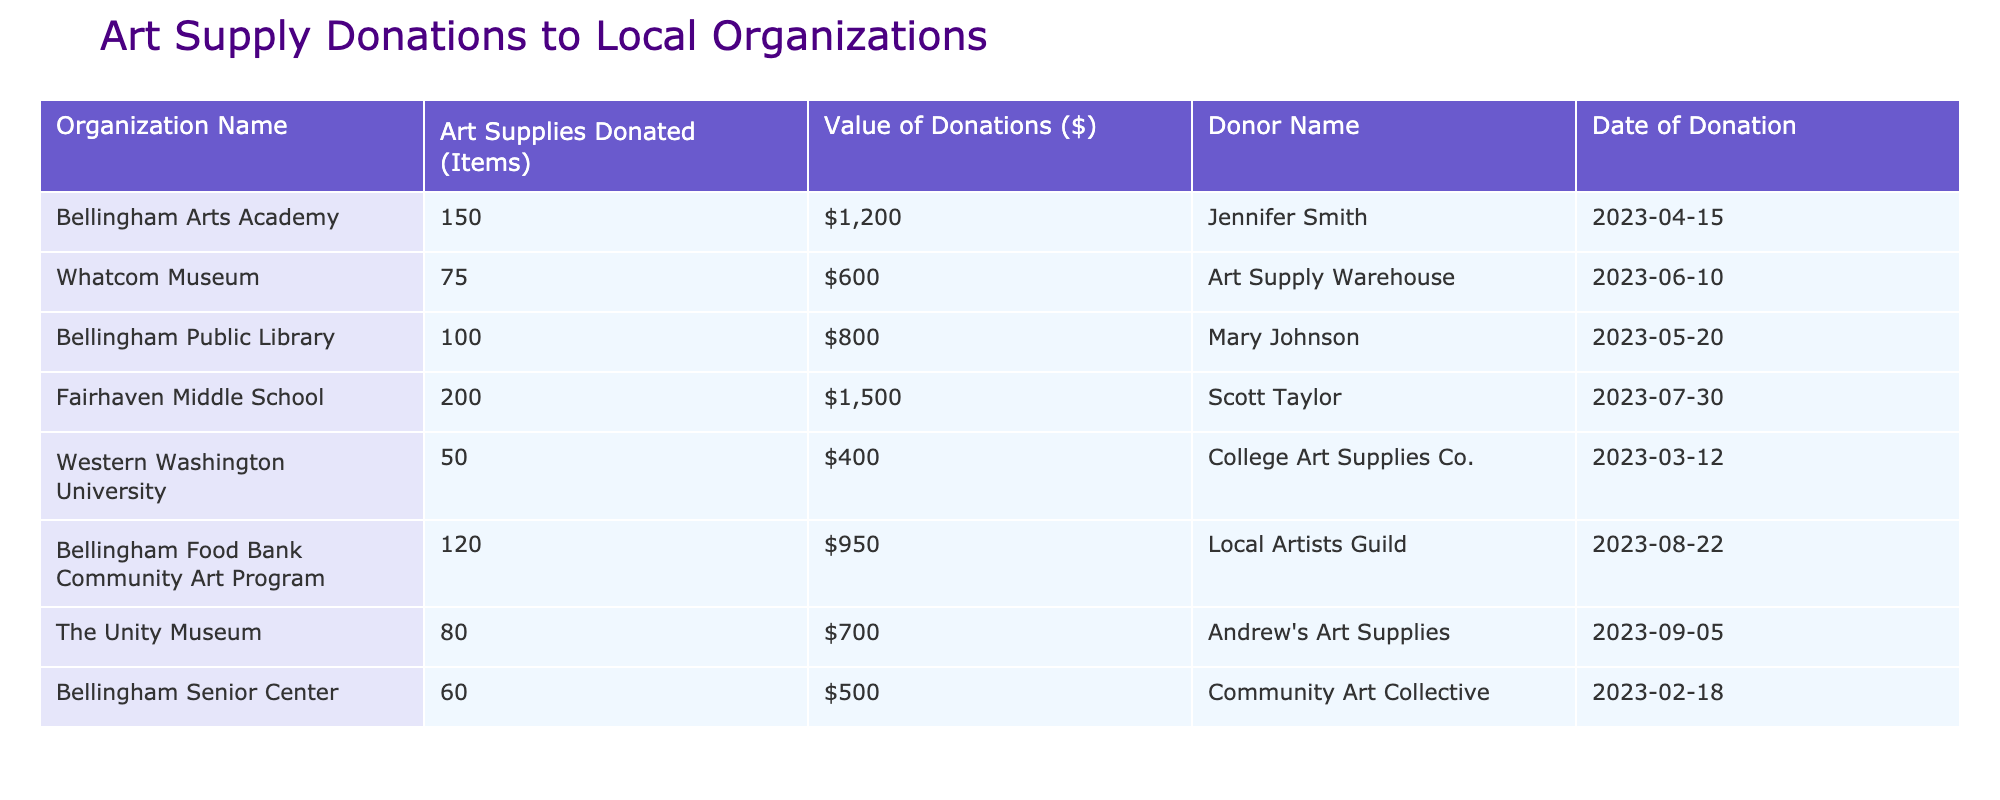What organization received the most art supplies? By examining the "Art Supplies Donated (Items)" column, Fairhaven Middle School has the highest number of items donated, with a total of 200.
Answer: Fairhaven Middle School What is the value of donations received by the Bellingham Public Library? Looking at the "Value of Donations ($)" column for the Bellingham Public Library, the value of donations is listed as $800.
Answer: $800 True or false: The Whatcom Museum received more than 500 dollars in art supply donations. The value of donations for the Whatcom Museum is $600, which is indeed greater than $500, making this statement true.
Answer: True What is the total number of items donated across all organizations? By summing the "Art Supplies Donated (Items)" column: 150 + 75 + 100 + 200 + 50 + 120 + 80 + 60 = 835. Therefore, the total number of items donated is 835.
Answer: 835 Which donor contributed to the highest value of donations and how much was donated? Analyzing the donor contributions, Scott Taylor donated to Fairhaven Middle School with a total value of $1,500, which is the highest among all donations.
Answer: $1,500 by Scott Taylor How many organizations received donations of more than 700 dollars? Looking at the "Value of Donations ($)" column, the organizations with donations exceeding $700 are Fairhaven Middle School ($1,500), Bellingham Arts Academy ($1,200), Bellingham Food Bank Community Art Program ($950), Whatcom Museum ($600) does not count. This totals to 3 organizations.
Answer: 3 organizations What is the average value of donations received by the organizations listed? Summing all donations gives: 1200 + 600 + 800 + 1500 + 400 + 950 + 700 + 500 = 5150. There are 8 organizations, so the average is 5150 / 8 = 643.75.
Answer: 643.75 Did any organization receive donations on the same day? Looking at the dates, each organization has a unique donation date, meaning that no two organizations received donations on the same day. Thus, this statement is false.
Answer: False 